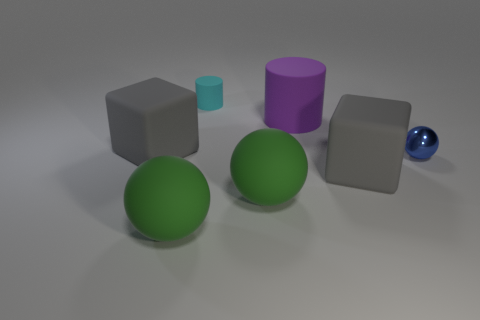Are there fewer big purple rubber objects than small purple rubber spheres?
Ensure brevity in your answer.  No. There is another cylinder that is the same material as the small cyan cylinder; what is its size?
Your response must be concise. Large. The blue metal ball is what size?
Ensure brevity in your answer.  Small. What is the shape of the big purple matte thing?
Give a very brief answer. Cylinder. Do the big matte block left of the tiny cyan matte object and the tiny shiny thing have the same color?
Keep it short and to the point. No. What size is the cyan thing that is the same shape as the large purple object?
Ensure brevity in your answer.  Small. Is there any other thing that has the same material as the small ball?
Provide a short and direct response. No. There is a big gray thing that is behind the rubber cube that is right of the tiny cyan matte thing; are there any purple matte objects in front of it?
Keep it short and to the point. No. There is a thing behind the purple rubber object; what material is it?
Ensure brevity in your answer.  Rubber. How many small objects are either shiny objects or cyan matte cylinders?
Your answer should be compact. 2. 